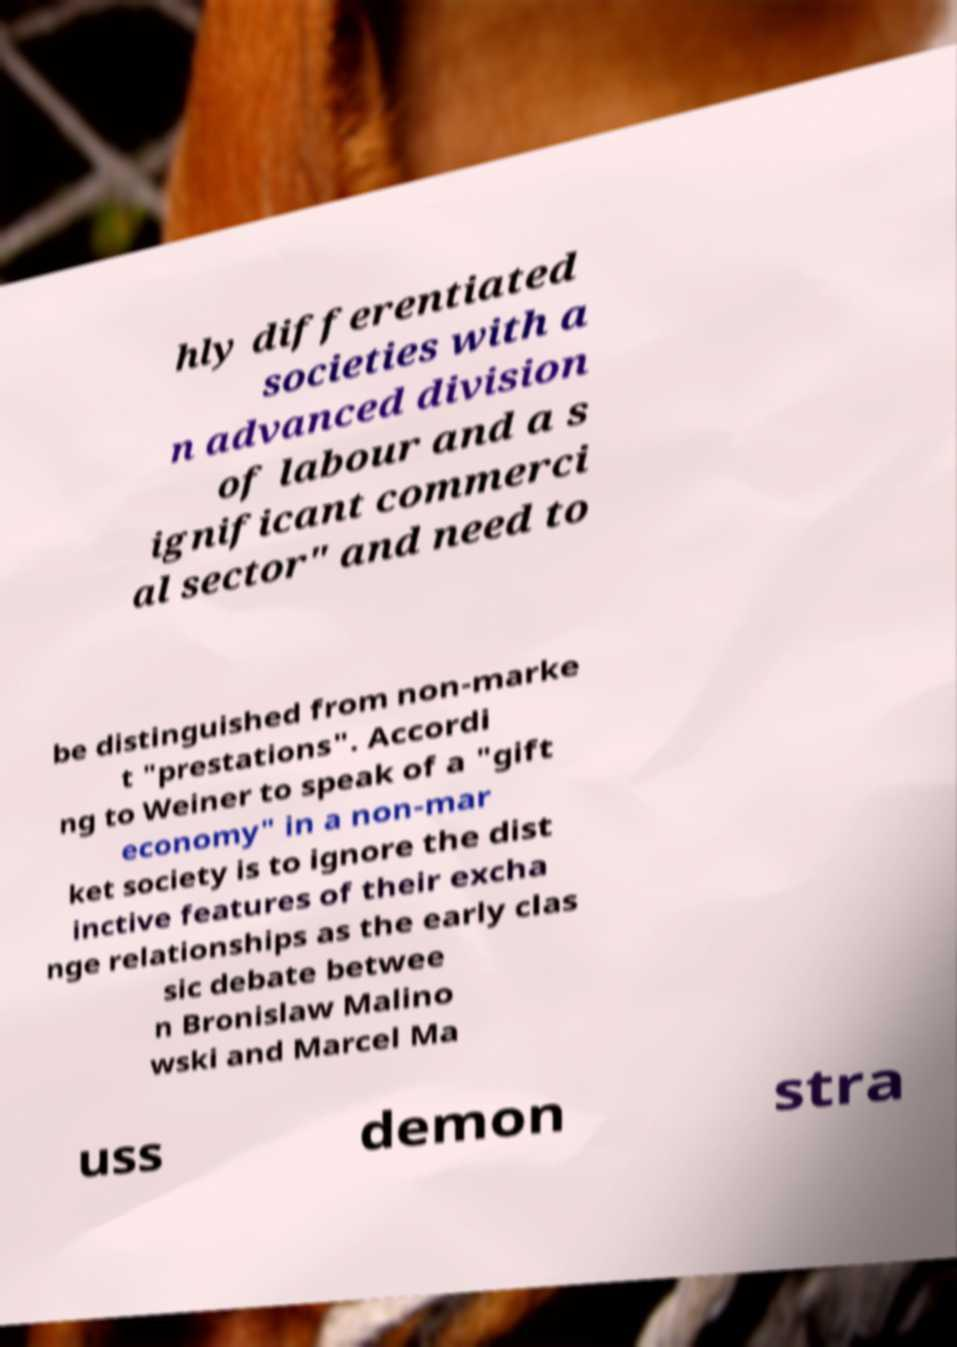Please identify and transcribe the text found in this image. hly differentiated societies with a n advanced division of labour and a s ignificant commerci al sector" and need to be distinguished from non-marke t "prestations". Accordi ng to Weiner to speak of a "gift economy" in a non-mar ket society is to ignore the dist inctive features of their excha nge relationships as the early clas sic debate betwee n Bronislaw Malino wski and Marcel Ma uss demon stra 